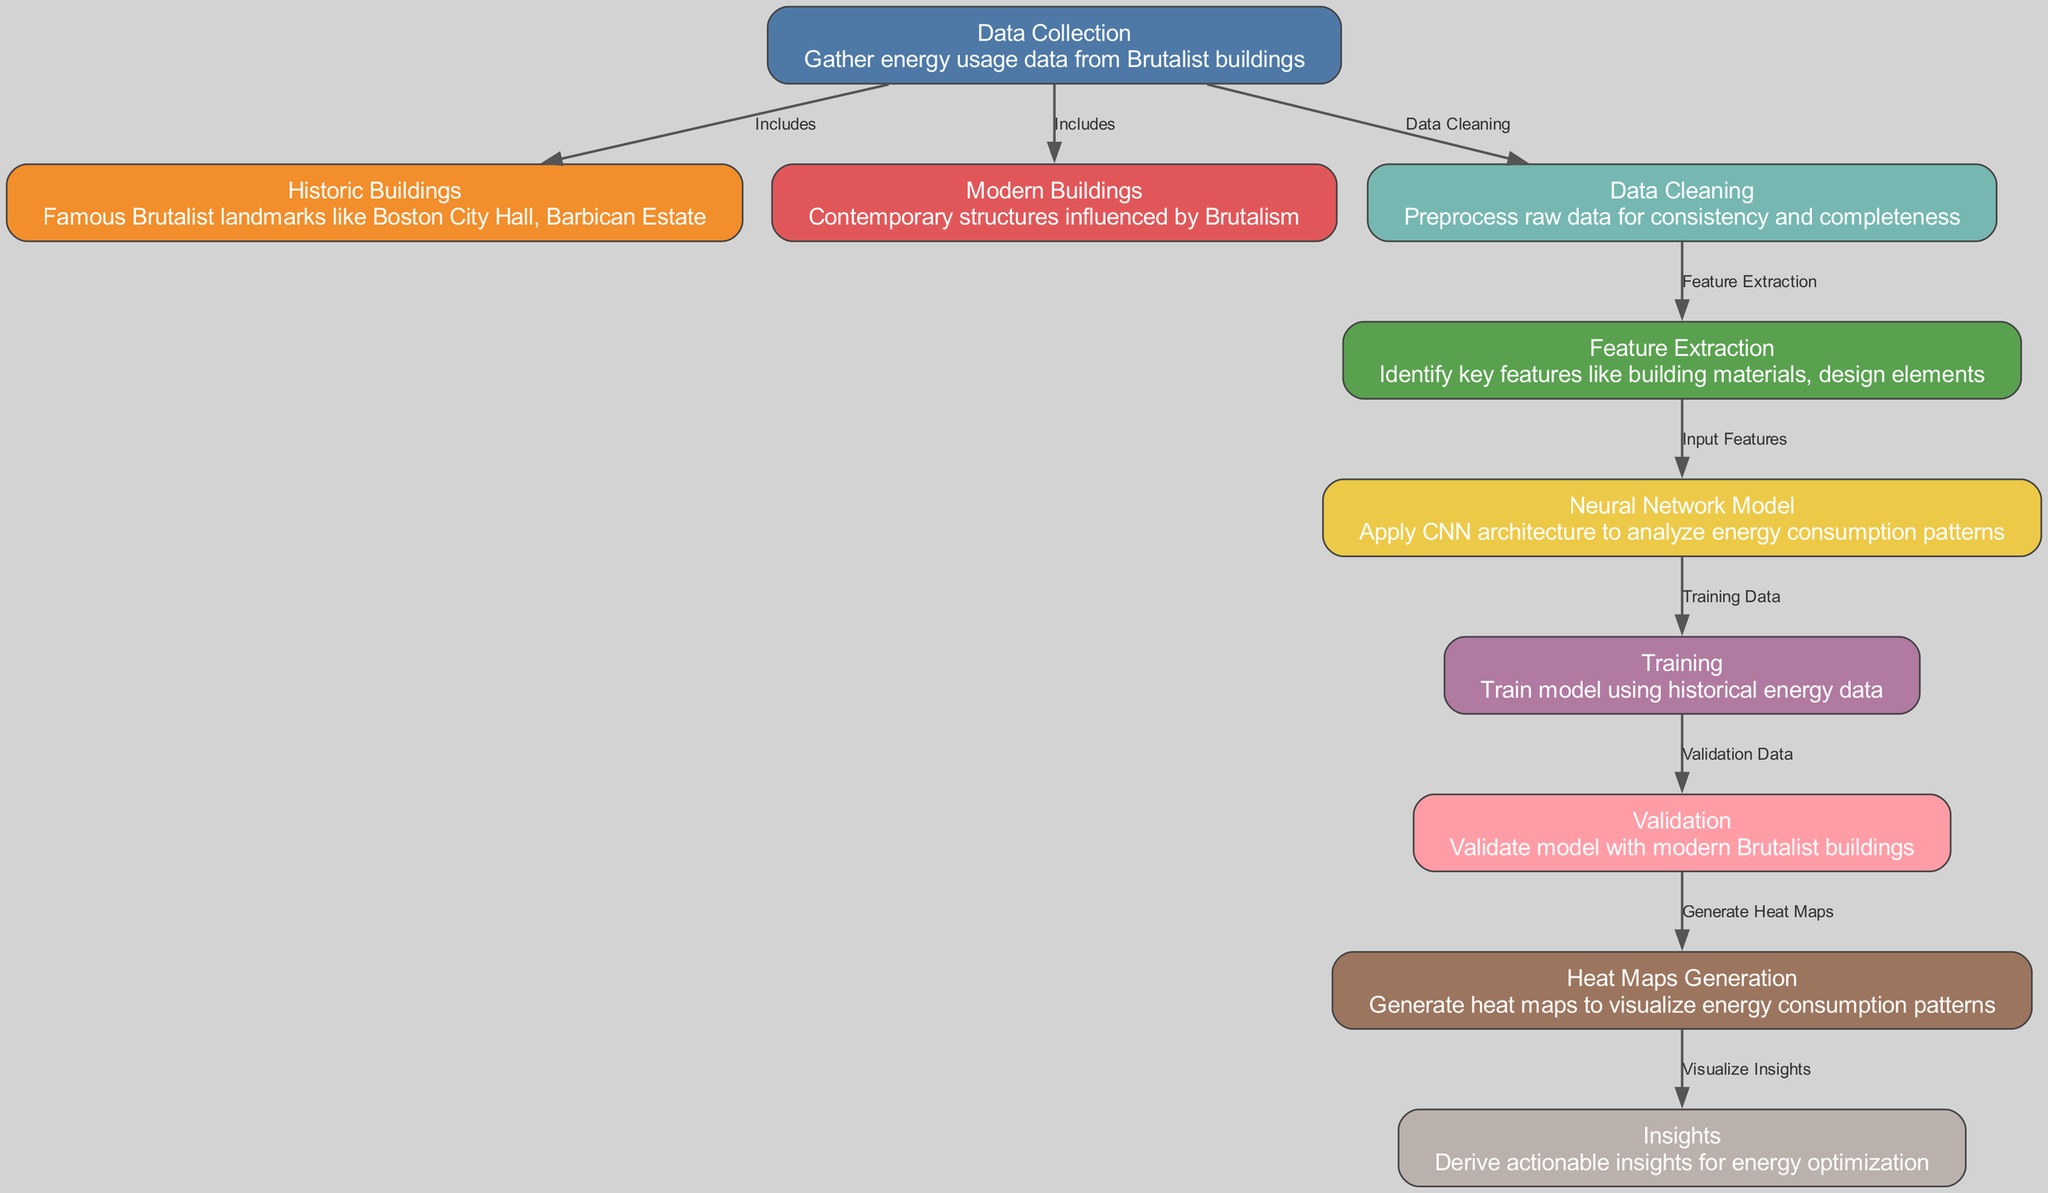What's the total number of nodes in the diagram? The diagram lists 10 distinct nodes, each representing different steps and elements in the energy consumption analysis process of Brutalist buildings.
Answer: 10 Identify the node that focuses on visualizing data. The "Heat Maps Generation" node is specifically concerned with generating heat maps, which are a visual representation of the energy consumption patterns.
Answer: Heat Maps Generation Which two types of buildings are included in the data collection? The data collection node connects to both "Historic Buildings" and "Modern Buildings", indicating that both types are included for energy usage data.
Answer: Historic Buildings, Modern Buildings What is the final output after generating heat maps? The final output is "Insights", which are actionable insights derived from the visualized energy consumption patterns in the heat maps.
Answer: Insights How does the training node connect to the validation node? The "Training" node provides "Validation Data" to the "Validation" node, establishing a flow from training the model to validating its performance using the data collected.
Answer: Validation Data What is the purpose of the feature extraction node? The feature extraction node identifies key features relevant to the model, such as building materials and design elements, which are crucial for analyzing energy consumption effectively.
Answer: Identify key features Which node involves preprocessing the raw data? The "Data Cleaning" node is responsible for preprocessing raw data to ensure consistency and completeness before further analysis is conducted.
Answer: Data Cleaning Which node is directly preceded by the training node? The "Validation" node follows the "Training" node, utilizing the trained model to validate its accuracy and performance against the modern building data.
Answer: Validation What type of model is applied in analyzing energy consumption? The "Neural Network Model" node indicates that a CNN architecture is specifically used to analyze the energy consumption patterns of the Brutalist buildings.
Answer: CNN architecture How are insights derived in the diagram? Insights are derived after generating heat maps, as they visualize the energy consumption patterns, allowing for actionable conclusions to be made.
Answer: Visualize Insights 